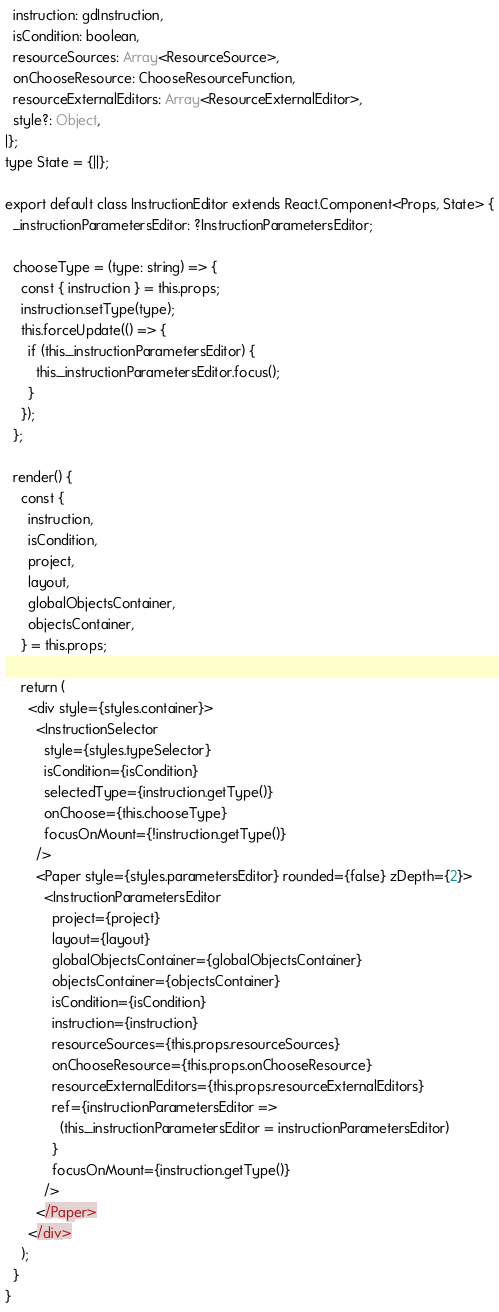Convert code to text. <code><loc_0><loc_0><loc_500><loc_500><_JavaScript_>  instruction: gdInstruction,
  isCondition: boolean,
  resourceSources: Array<ResourceSource>,
  onChooseResource: ChooseResourceFunction,
  resourceExternalEditors: Array<ResourceExternalEditor>,
  style?: Object,
|};
type State = {||};

export default class InstructionEditor extends React.Component<Props, State> {
  _instructionParametersEditor: ?InstructionParametersEditor;

  chooseType = (type: string) => {
    const { instruction } = this.props;
    instruction.setType(type);
    this.forceUpdate(() => {
      if (this._instructionParametersEditor) {
        this._instructionParametersEditor.focus();
      }
    });
  };

  render() {
    const {
      instruction,
      isCondition,
      project,
      layout,
      globalObjectsContainer,
      objectsContainer,
    } = this.props;

    return (
      <div style={styles.container}>
        <InstructionSelector
          style={styles.typeSelector}
          isCondition={isCondition}
          selectedType={instruction.getType()}
          onChoose={this.chooseType}
          focusOnMount={!instruction.getType()}
        />
        <Paper style={styles.parametersEditor} rounded={false} zDepth={2}>
          <InstructionParametersEditor
            project={project}
            layout={layout}
            globalObjectsContainer={globalObjectsContainer}
            objectsContainer={objectsContainer}
            isCondition={isCondition}
            instruction={instruction}
            resourceSources={this.props.resourceSources}
            onChooseResource={this.props.onChooseResource}
            resourceExternalEditors={this.props.resourceExternalEditors}
            ref={instructionParametersEditor =>
              (this._instructionParametersEditor = instructionParametersEditor)
            }
            focusOnMount={instruction.getType()}
          />
        </Paper>
      </div>
    );
  }
}
</code> 